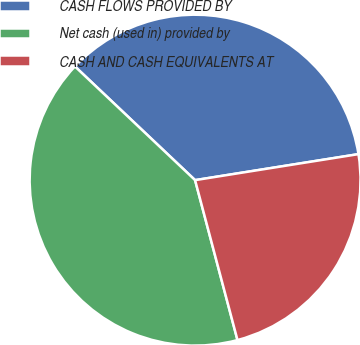Convert chart. <chart><loc_0><loc_0><loc_500><loc_500><pie_chart><fcel>CASH FLOWS PROVIDED BY<fcel>Net cash (used in) provided by<fcel>CASH AND CASH EQUIVALENTS AT<nl><fcel>35.43%<fcel>41.19%<fcel>23.39%<nl></chart> 